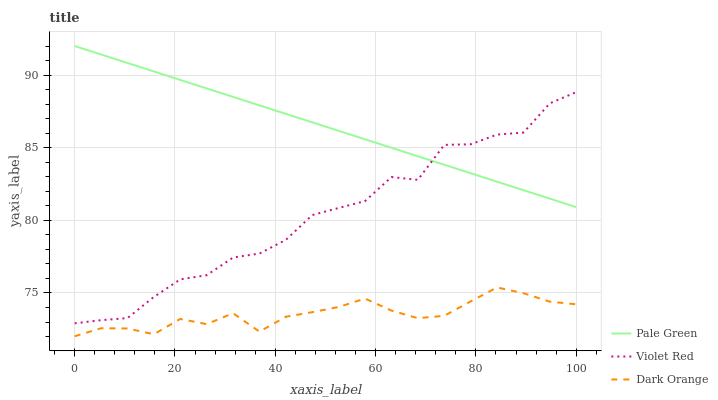Does Dark Orange have the minimum area under the curve?
Answer yes or no. Yes. Does Pale Green have the maximum area under the curve?
Answer yes or no. Yes. Does Violet Red have the minimum area under the curve?
Answer yes or no. No. Does Violet Red have the maximum area under the curve?
Answer yes or no. No. Is Pale Green the smoothest?
Answer yes or no. Yes. Is Violet Red the roughest?
Answer yes or no. Yes. Is Violet Red the smoothest?
Answer yes or no. No. Is Pale Green the roughest?
Answer yes or no. No. Does Dark Orange have the lowest value?
Answer yes or no. Yes. Does Violet Red have the lowest value?
Answer yes or no. No. Does Pale Green have the highest value?
Answer yes or no. Yes. Does Violet Red have the highest value?
Answer yes or no. No. Is Dark Orange less than Pale Green?
Answer yes or no. Yes. Is Pale Green greater than Dark Orange?
Answer yes or no. Yes. Does Violet Red intersect Pale Green?
Answer yes or no. Yes. Is Violet Red less than Pale Green?
Answer yes or no. No. Is Violet Red greater than Pale Green?
Answer yes or no. No. Does Dark Orange intersect Pale Green?
Answer yes or no. No. 